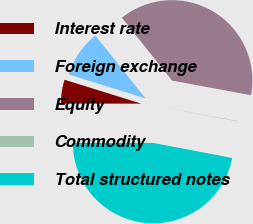<chart> <loc_0><loc_0><loc_500><loc_500><pie_chart><fcel>Interest rate<fcel>Foreign exchange<fcel>Equity<fcel>Commodity<fcel>Total structured notes<nl><fcel>4.78%<fcel>9.47%<fcel>38.64%<fcel>0.08%<fcel>47.03%<nl></chart> 